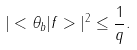<formula> <loc_0><loc_0><loc_500><loc_500>| < \theta _ { b } | f > | ^ { 2 } \leq \frac { 1 } { q } .</formula> 